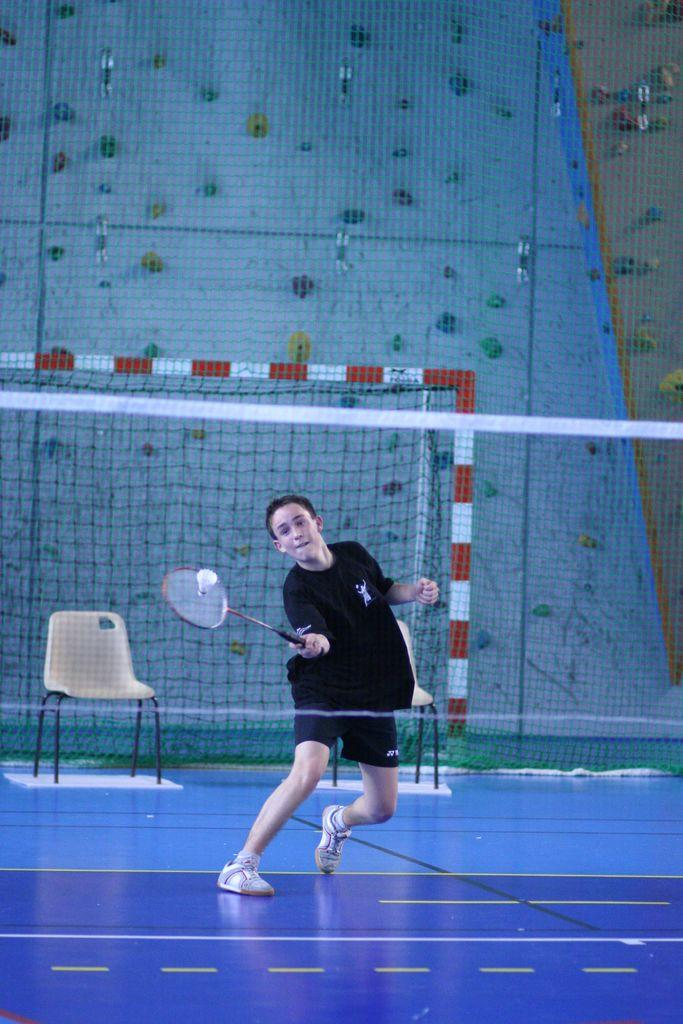What activity is the person in the image engaged in? The person is playing badminton. What color is the shirt the person is wearing? The person is wearing a black shirt. What type of clothing is the person wearing on their lower body? The person is wearing shorts. What is separating the person from their opponent in the game? There is a net in front of the person. What piece of furniture can be seen behind the person? There is a chair behind the person. What is the color of the floor in the image? The floor is blue in color. What type of chain can be seen around the person's neck in the image? There is no chain visible around the person's neck in the image. What achievement has the person recently accomplished, as seen in the image? The image does not provide any information about the person's recent achievements. 